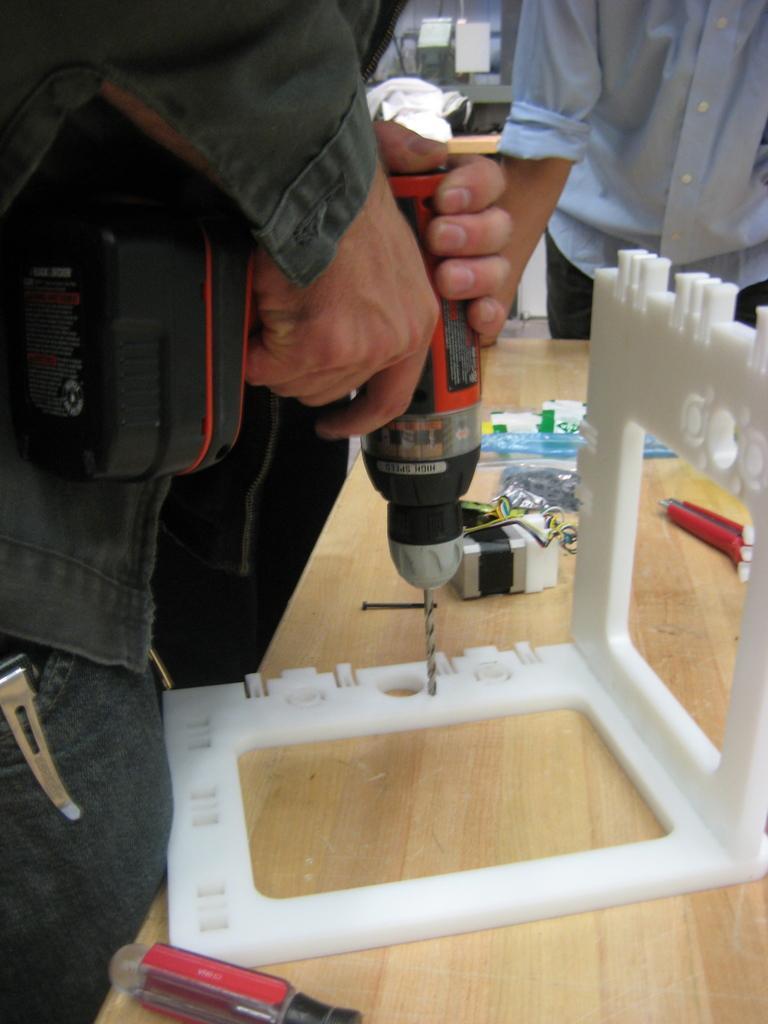How would you summarize this image in a sentence or two? In this image I can see two persons are standing and I can see one of them is holding a drill machine. I can also see a table and on it I can see a white colour thing, a screwdriver and few other stuffs. In the background I can see few white colour things and on the left side of this image I can see an object in the one person's pocket. 